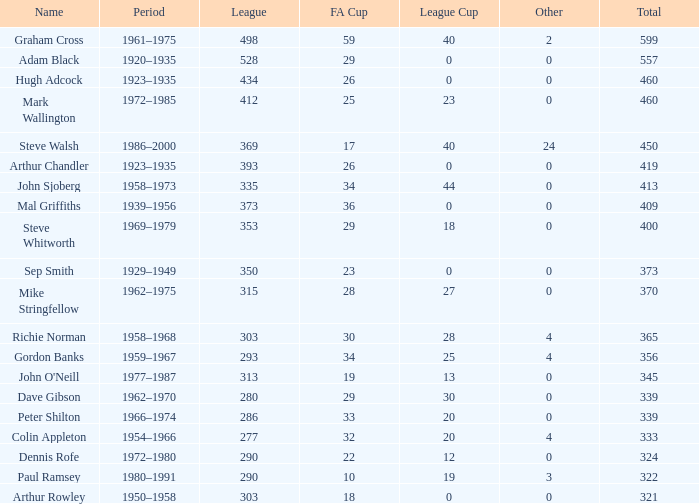What is the lowest number of League Cups a player with a 434 league has? 0.0. 